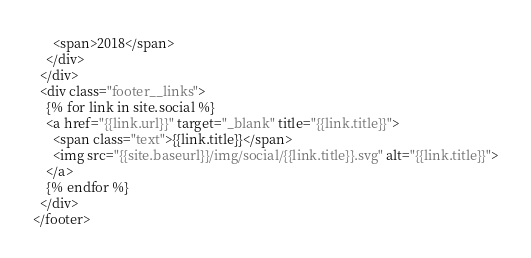Convert code to text. <code><loc_0><loc_0><loc_500><loc_500><_HTML_>      <span>2018</span>
    </div>
  </div>
  <div class="footer__links">
    {% for link in site.social %}
    <a href="{{link.url}}" target="_blank" title="{{link.title}}">
      <span class="text">{{link.title}}</span>
      <img src="{{site.baseurl}}/img/social/{{link.title}}.svg" alt="{{link.title}}">
    </a>
    {% endfor %}
  </div>
</footer>
</code> 